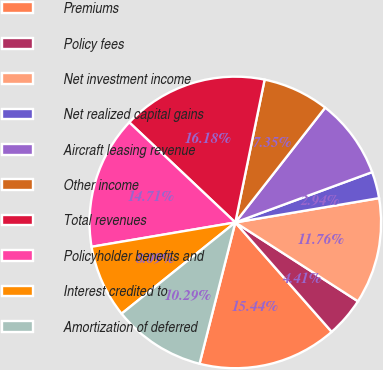<chart> <loc_0><loc_0><loc_500><loc_500><pie_chart><fcel>Premiums<fcel>Policy fees<fcel>Net investment income<fcel>Net realized capital gains<fcel>Aircraft leasing revenue<fcel>Other income<fcel>Total revenues<fcel>Policyholder benefits and<fcel>Interest credited to<fcel>Amortization of deferred<nl><fcel>15.44%<fcel>4.41%<fcel>11.76%<fcel>2.94%<fcel>8.82%<fcel>7.35%<fcel>16.18%<fcel>14.71%<fcel>8.09%<fcel>10.29%<nl></chart> 